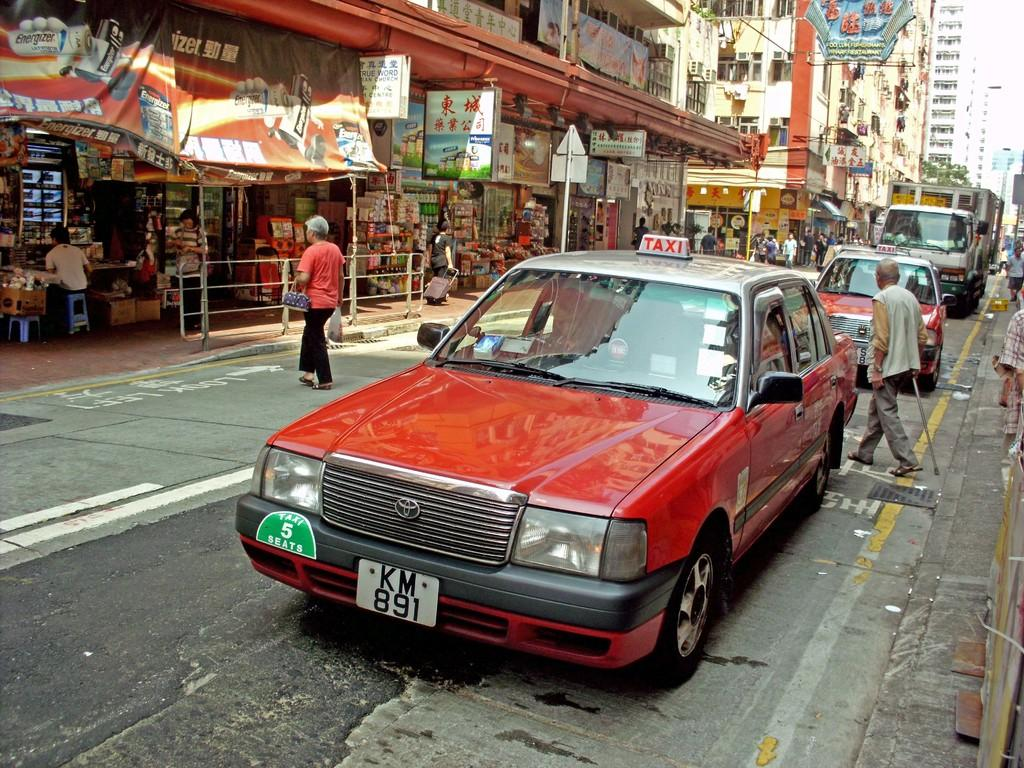<image>
Render a clear and concise summary of the photo. A red taxi on a narrow street with license plate KM 891. 